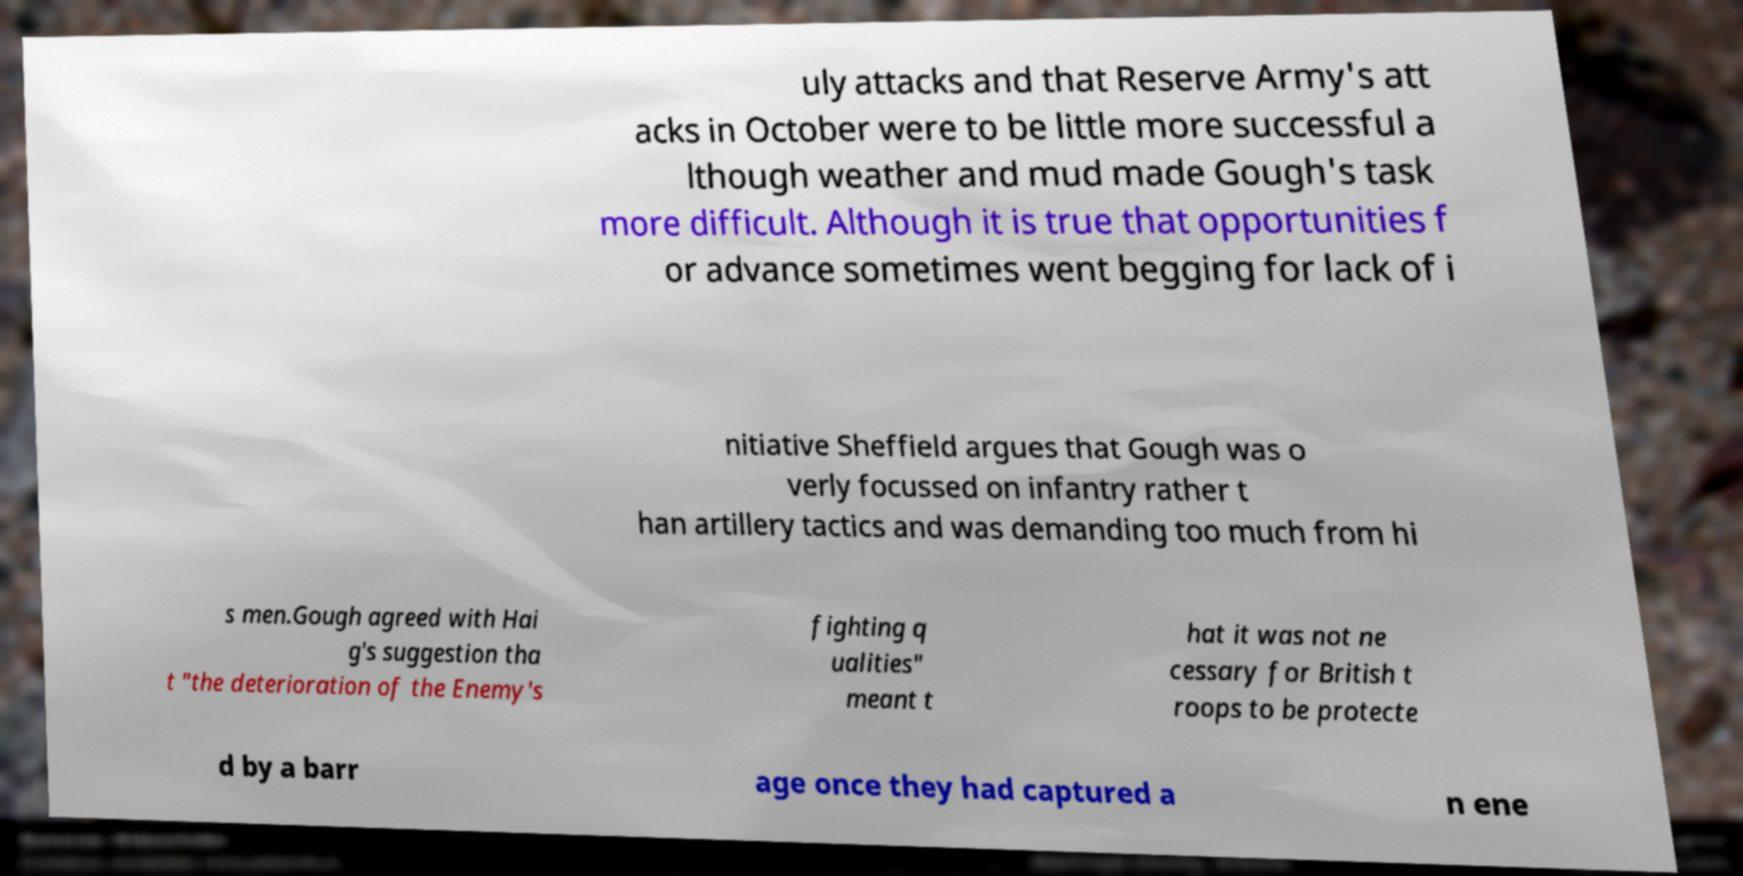For documentation purposes, I need the text within this image transcribed. Could you provide that? uly attacks and that Reserve Army's att acks in October were to be little more successful a lthough weather and mud made Gough's task more difficult. Although it is true that opportunities f or advance sometimes went begging for lack of i nitiative Sheffield argues that Gough was o verly focussed on infantry rather t han artillery tactics and was demanding too much from hi s men.Gough agreed with Hai g's suggestion tha t "the deterioration of the Enemy's fighting q ualities" meant t hat it was not ne cessary for British t roops to be protecte d by a barr age once they had captured a n ene 